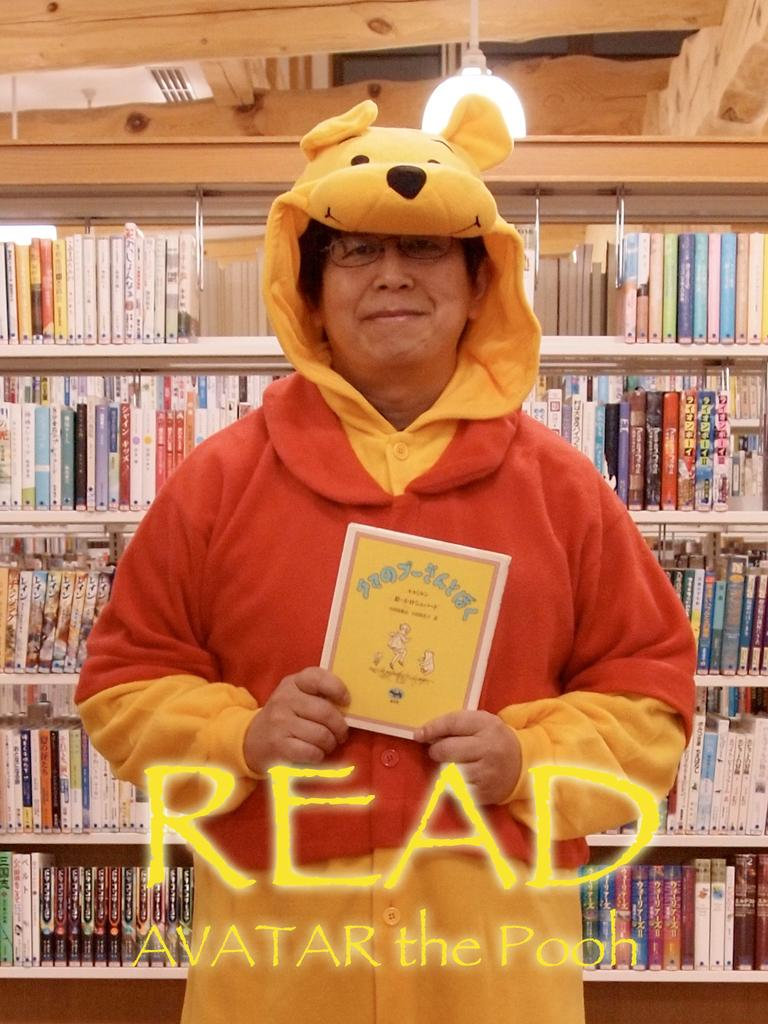What is the person in the image doing? The person is standing in the front of the image and holding a card. What can be seen in the background of the image? There is a light, a rack, and books in the background of the image. Is there any text or writing visible in the image? Yes, there is writing on the image. How many snakes are coiled around the light in the image? There are no snakes present in the image; the light is not surrounded by any snakes. 